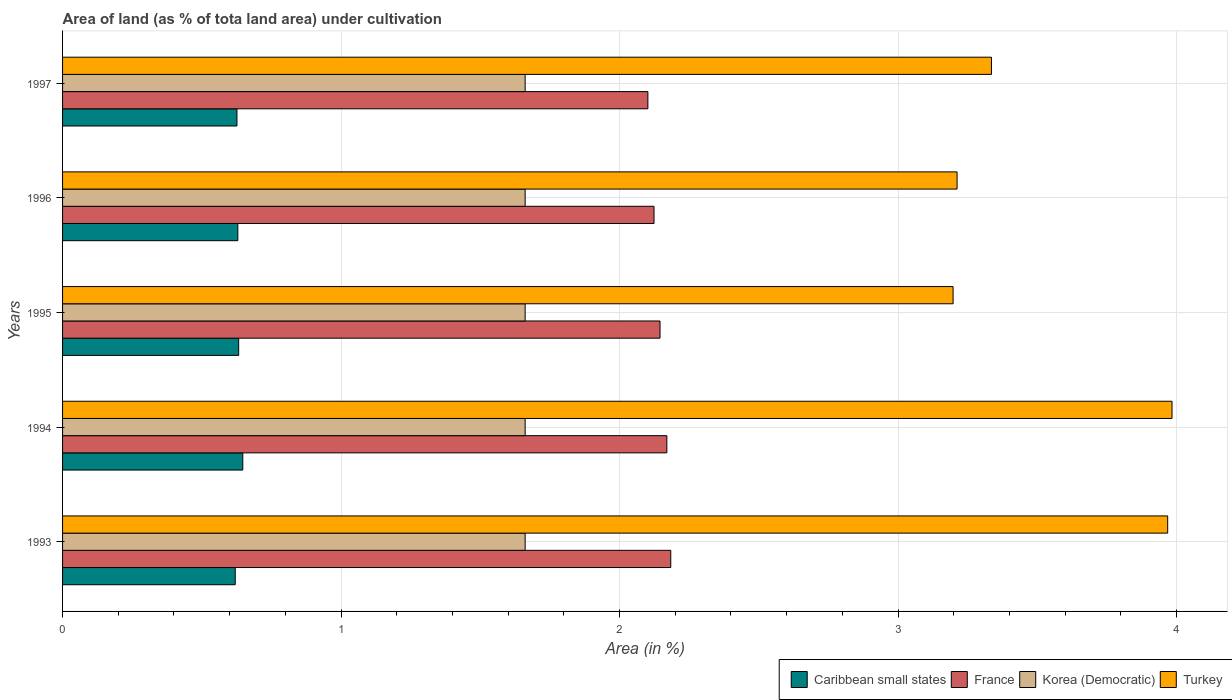How many groups of bars are there?
Make the answer very short. 5. How many bars are there on the 4th tick from the top?
Give a very brief answer. 4. How many bars are there on the 2nd tick from the bottom?
Offer a terse response. 4. What is the percentage of land under cultivation in France in 1997?
Offer a terse response. 2.1. Across all years, what is the maximum percentage of land under cultivation in Turkey?
Provide a short and direct response. 3.98. Across all years, what is the minimum percentage of land under cultivation in France?
Offer a very short reply. 2.1. In which year was the percentage of land under cultivation in Korea (Democratic) maximum?
Your response must be concise. 1993. What is the total percentage of land under cultivation in Caribbean small states in the graph?
Provide a short and direct response. 3.15. What is the difference between the percentage of land under cultivation in France in 1995 and that in 1997?
Offer a terse response. 0.04. What is the difference between the percentage of land under cultivation in Turkey in 1993 and the percentage of land under cultivation in Korea (Democratic) in 1994?
Offer a terse response. 2.31. What is the average percentage of land under cultivation in Turkey per year?
Your answer should be very brief. 3.54. In the year 1995, what is the difference between the percentage of land under cultivation in Turkey and percentage of land under cultivation in France?
Provide a succinct answer. 1.05. In how many years, is the percentage of land under cultivation in France greater than 3.6 %?
Your response must be concise. 0. What is the ratio of the percentage of land under cultivation in Korea (Democratic) in 1993 to that in 1996?
Offer a terse response. 1. Is the percentage of land under cultivation in France in 1996 less than that in 1997?
Ensure brevity in your answer.  No. What is the difference between the highest and the second highest percentage of land under cultivation in Turkey?
Give a very brief answer. 0.02. What is the difference between the highest and the lowest percentage of land under cultivation in Korea (Democratic)?
Your answer should be compact. 0. In how many years, is the percentage of land under cultivation in Turkey greater than the average percentage of land under cultivation in Turkey taken over all years?
Provide a succinct answer. 2. Is the sum of the percentage of land under cultivation in Caribbean small states in 1995 and 1996 greater than the maximum percentage of land under cultivation in France across all years?
Your answer should be compact. No. What does the 4th bar from the top in 1995 represents?
Make the answer very short. Caribbean small states. What does the 3rd bar from the bottom in 1994 represents?
Offer a very short reply. Korea (Democratic). Is it the case that in every year, the sum of the percentage of land under cultivation in France and percentage of land under cultivation in Korea (Democratic) is greater than the percentage of land under cultivation in Turkey?
Your response must be concise. No. How many bars are there?
Provide a succinct answer. 20. Are all the bars in the graph horizontal?
Keep it short and to the point. Yes. How many years are there in the graph?
Make the answer very short. 5. What is the difference between two consecutive major ticks on the X-axis?
Ensure brevity in your answer.  1. Are the values on the major ticks of X-axis written in scientific E-notation?
Your answer should be very brief. No. Does the graph contain any zero values?
Your answer should be very brief. No. Does the graph contain grids?
Offer a terse response. Yes. How are the legend labels stacked?
Give a very brief answer. Horizontal. What is the title of the graph?
Keep it short and to the point. Area of land (as % of tota land area) under cultivation. What is the label or title of the X-axis?
Your answer should be compact. Area (in %). What is the label or title of the Y-axis?
Your response must be concise. Years. What is the Area (in %) of Caribbean small states in 1993?
Give a very brief answer. 0.62. What is the Area (in %) in France in 1993?
Your response must be concise. 2.18. What is the Area (in %) in Korea (Democratic) in 1993?
Offer a terse response. 1.66. What is the Area (in %) of Turkey in 1993?
Provide a short and direct response. 3.97. What is the Area (in %) of Caribbean small states in 1994?
Give a very brief answer. 0.65. What is the Area (in %) in France in 1994?
Ensure brevity in your answer.  2.17. What is the Area (in %) in Korea (Democratic) in 1994?
Ensure brevity in your answer.  1.66. What is the Area (in %) of Turkey in 1994?
Keep it short and to the point. 3.98. What is the Area (in %) in Caribbean small states in 1995?
Your response must be concise. 0.63. What is the Area (in %) of France in 1995?
Keep it short and to the point. 2.15. What is the Area (in %) of Korea (Democratic) in 1995?
Your response must be concise. 1.66. What is the Area (in %) in Turkey in 1995?
Offer a very short reply. 3.2. What is the Area (in %) in Caribbean small states in 1996?
Ensure brevity in your answer.  0.63. What is the Area (in %) of France in 1996?
Give a very brief answer. 2.12. What is the Area (in %) of Korea (Democratic) in 1996?
Your answer should be compact. 1.66. What is the Area (in %) of Turkey in 1996?
Offer a very short reply. 3.21. What is the Area (in %) in Caribbean small states in 1997?
Give a very brief answer. 0.63. What is the Area (in %) in France in 1997?
Your response must be concise. 2.1. What is the Area (in %) of Korea (Democratic) in 1997?
Offer a very short reply. 1.66. What is the Area (in %) of Turkey in 1997?
Your answer should be compact. 3.34. Across all years, what is the maximum Area (in %) in Caribbean small states?
Ensure brevity in your answer.  0.65. Across all years, what is the maximum Area (in %) of France?
Your response must be concise. 2.18. Across all years, what is the maximum Area (in %) of Korea (Democratic)?
Give a very brief answer. 1.66. Across all years, what is the maximum Area (in %) of Turkey?
Provide a short and direct response. 3.98. Across all years, what is the minimum Area (in %) in Caribbean small states?
Your response must be concise. 0.62. Across all years, what is the minimum Area (in %) of France?
Provide a short and direct response. 2.1. Across all years, what is the minimum Area (in %) in Korea (Democratic)?
Provide a short and direct response. 1.66. Across all years, what is the minimum Area (in %) in Turkey?
Offer a terse response. 3.2. What is the total Area (in %) of Caribbean small states in the graph?
Keep it short and to the point. 3.15. What is the total Area (in %) of France in the graph?
Provide a short and direct response. 10.72. What is the total Area (in %) in Korea (Democratic) in the graph?
Provide a short and direct response. 8.3. What is the total Area (in %) of Turkey in the graph?
Make the answer very short. 17.7. What is the difference between the Area (in %) of Caribbean small states in 1993 and that in 1994?
Offer a very short reply. -0.03. What is the difference between the Area (in %) of France in 1993 and that in 1994?
Give a very brief answer. 0.01. What is the difference between the Area (in %) of Korea (Democratic) in 1993 and that in 1994?
Your answer should be very brief. 0. What is the difference between the Area (in %) of Turkey in 1993 and that in 1994?
Offer a very short reply. -0.02. What is the difference between the Area (in %) in Caribbean small states in 1993 and that in 1995?
Give a very brief answer. -0.01. What is the difference between the Area (in %) in France in 1993 and that in 1995?
Your answer should be very brief. 0.04. What is the difference between the Area (in %) of Turkey in 1993 and that in 1995?
Offer a very short reply. 0.77. What is the difference between the Area (in %) of Caribbean small states in 1993 and that in 1996?
Provide a short and direct response. -0.01. What is the difference between the Area (in %) of France in 1993 and that in 1996?
Your answer should be compact. 0.06. What is the difference between the Area (in %) of Turkey in 1993 and that in 1996?
Make the answer very short. 0.76. What is the difference between the Area (in %) of Caribbean small states in 1993 and that in 1997?
Offer a terse response. -0.01. What is the difference between the Area (in %) in France in 1993 and that in 1997?
Make the answer very short. 0.08. What is the difference between the Area (in %) in Turkey in 1993 and that in 1997?
Provide a succinct answer. 0.63. What is the difference between the Area (in %) of Caribbean small states in 1994 and that in 1995?
Your response must be concise. 0.01. What is the difference between the Area (in %) in France in 1994 and that in 1995?
Offer a terse response. 0.02. What is the difference between the Area (in %) in Turkey in 1994 and that in 1995?
Make the answer very short. 0.79. What is the difference between the Area (in %) in Caribbean small states in 1994 and that in 1996?
Keep it short and to the point. 0.02. What is the difference between the Area (in %) in France in 1994 and that in 1996?
Keep it short and to the point. 0.05. What is the difference between the Area (in %) in Turkey in 1994 and that in 1996?
Offer a very short reply. 0.77. What is the difference between the Area (in %) of Caribbean small states in 1994 and that in 1997?
Make the answer very short. 0.02. What is the difference between the Area (in %) in France in 1994 and that in 1997?
Make the answer very short. 0.07. What is the difference between the Area (in %) in Turkey in 1994 and that in 1997?
Make the answer very short. 0.65. What is the difference between the Area (in %) of Caribbean small states in 1995 and that in 1996?
Give a very brief answer. 0. What is the difference between the Area (in %) in France in 1995 and that in 1996?
Ensure brevity in your answer.  0.02. What is the difference between the Area (in %) of Korea (Democratic) in 1995 and that in 1996?
Provide a short and direct response. 0. What is the difference between the Area (in %) in Turkey in 1995 and that in 1996?
Provide a succinct answer. -0.01. What is the difference between the Area (in %) in Caribbean small states in 1995 and that in 1997?
Provide a short and direct response. 0.01. What is the difference between the Area (in %) in France in 1995 and that in 1997?
Give a very brief answer. 0.04. What is the difference between the Area (in %) of Korea (Democratic) in 1995 and that in 1997?
Your response must be concise. 0. What is the difference between the Area (in %) in Turkey in 1995 and that in 1997?
Offer a terse response. -0.14. What is the difference between the Area (in %) of Caribbean small states in 1996 and that in 1997?
Provide a short and direct response. 0. What is the difference between the Area (in %) in France in 1996 and that in 1997?
Keep it short and to the point. 0.02. What is the difference between the Area (in %) in Korea (Democratic) in 1996 and that in 1997?
Keep it short and to the point. 0. What is the difference between the Area (in %) of Turkey in 1996 and that in 1997?
Provide a short and direct response. -0.12. What is the difference between the Area (in %) in Caribbean small states in 1993 and the Area (in %) in France in 1994?
Make the answer very short. -1.55. What is the difference between the Area (in %) of Caribbean small states in 1993 and the Area (in %) of Korea (Democratic) in 1994?
Give a very brief answer. -1.04. What is the difference between the Area (in %) of Caribbean small states in 1993 and the Area (in %) of Turkey in 1994?
Provide a succinct answer. -3.36. What is the difference between the Area (in %) in France in 1993 and the Area (in %) in Korea (Democratic) in 1994?
Your answer should be compact. 0.52. What is the difference between the Area (in %) of France in 1993 and the Area (in %) of Turkey in 1994?
Offer a very short reply. -1.8. What is the difference between the Area (in %) in Korea (Democratic) in 1993 and the Area (in %) in Turkey in 1994?
Provide a short and direct response. -2.32. What is the difference between the Area (in %) of Caribbean small states in 1993 and the Area (in %) of France in 1995?
Provide a succinct answer. -1.53. What is the difference between the Area (in %) in Caribbean small states in 1993 and the Area (in %) in Korea (Democratic) in 1995?
Offer a very short reply. -1.04. What is the difference between the Area (in %) in Caribbean small states in 1993 and the Area (in %) in Turkey in 1995?
Provide a succinct answer. -2.58. What is the difference between the Area (in %) of France in 1993 and the Area (in %) of Korea (Democratic) in 1995?
Provide a short and direct response. 0.52. What is the difference between the Area (in %) of France in 1993 and the Area (in %) of Turkey in 1995?
Provide a short and direct response. -1.01. What is the difference between the Area (in %) in Korea (Democratic) in 1993 and the Area (in %) in Turkey in 1995?
Your response must be concise. -1.54. What is the difference between the Area (in %) of Caribbean small states in 1993 and the Area (in %) of France in 1996?
Keep it short and to the point. -1.5. What is the difference between the Area (in %) in Caribbean small states in 1993 and the Area (in %) in Korea (Democratic) in 1996?
Give a very brief answer. -1.04. What is the difference between the Area (in %) of Caribbean small states in 1993 and the Area (in %) of Turkey in 1996?
Provide a succinct answer. -2.59. What is the difference between the Area (in %) in France in 1993 and the Area (in %) in Korea (Democratic) in 1996?
Make the answer very short. 0.52. What is the difference between the Area (in %) of France in 1993 and the Area (in %) of Turkey in 1996?
Your answer should be very brief. -1.03. What is the difference between the Area (in %) in Korea (Democratic) in 1993 and the Area (in %) in Turkey in 1996?
Offer a terse response. -1.55. What is the difference between the Area (in %) in Caribbean small states in 1993 and the Area (in %) in France in 1997?
Give a very brief answer. -1.48. What is the difference between the Area (in %) in Caribbean small states in 1993 and the Area (in %) in Korea (Democratic) in 1997?
Your answer should be compact. -1.04. What is the difference between the Area (in %) in Caribbean small states in 1993 and the Area (in %) in Turkey in 1997?
Offer a terse response. -2.72. What is the difference between the Area (in %) in France in 1993 and the Area (in %) in Korea (Democratic) in 1997?
Provide a succinct answer. 0.52. What is the difference between the Area (in %) of France in 1993 and the Area (in %) of Turkey in 1997?
Your answer should be compact. -1.15. What is the difference between the Area (in %) of Korea (Democratic) in 1993 and the Area (in %) of Turkey in 1997?
Offer a very short reply. -1.67. What is the difference between the Area (in %) in Caribbean small states in 1994 and the Area (in %) in France in 1995?
Offer a terse response. -1.5. What is the difference between the Area (in %) in Caribbean small states in 1994 and the Area (in %) in Korea (Democratic) in 1995?
Your answer should be very brief. -1.01. What is the difference between the Area (in %) of Caribbean small states in 1994 and the Area (in %) of Turkey in 1995?
Keep it short and to the point. -2.55. What is the difference between the Area (in %) in France in 1994 and the Area (in %) in Korea (Democratic) in 1995?
Make the answer very short. 0.51. What is the difference between the Area (in %) in France in 1994 and the Area (in %) in Turkey in 1995?
Keep it short and to the point. -1.03. What is the difference between the Area (in %) in Korea (Democratic) in 1994 and the Area (in %) in Turkey in 1995?
Give a very brief answer. -1.54. What is the difference between the Area (in %) in Caribbean small states in 1994 and the Area (in %) in France in 1996?
Offer a terse response. -1.48. What is the difference between the Area (in %) in Caribbean small states in 1994 and the Area (in %) in Korea (Democratic) in 1996?
Keep it short and to the point. -1.01. What is the difference between the Area (in %) in Caribbean small states in 1994 and the Area (in %) in Turkey in 1996?
Make the answer very short. -2.56. What is the difference between the Area (in %) of France in 1994 and the Area (in %) of Korea (Democratic) in 1996?
Make the answer very short. 0.51. What is the difference between the Area (in %) in France in 1994 and the Area (in %) in Turkey in 1996?
Offer a very short reply. -1.04. What is the difference between the Area (in %) of Korea (Democratic) in 1994 and the Area (in %) of Turkey in 1996?
Make the answer very short. -1.55. What is the difference between the Area (in %) in Caribbean small states in 1994 and the Area (in %) in France in 1997?
Your answer should be very brief. -1.45. What is the difference between the Area (in %) in Caribbean small states in 1994 and the Area (in %) in Korea (Democratic) in 1997?
Your answer should be compact. -1.01. What is the difference between the Area (in %) of Caribbean small states in 1994 and the Area (in %) of Turkey in 1997?
Your answer should be compact. -2.69. What is the difference between the Area (in %) in France in 1994 and the Area (in %) in Korea (Democratic) in 1997?
Keep it short and to the point. 0.51. What is the difference between the Area (in %) of France in 1994 and the Area (in %) of Turkey in 1997?
Provide a succinct answer. -1.17. What is the difference between the Area (in %) in Korea (Democratic) in 1994 and the Area (in %) in Turkey in 1997?
Offer a terse response. -1.67. What is the difference between the Area (in %) in Caribbean small states in 1995 and the Area (in %) in France in 1996?
Your answer should be very brief. -1.49. What is the difference between the Area (in %) in Caribbean small states in 1995 and the Area (in %) in Korea (Democratic) in 1996?
Provide a short and direct response. -1.03. What is the difference between the Area (in %) in Caribbean small states in 1995 and the Area (in %) in Turkey in 1996?
Your answer should be compact. -2.58. What is the difference between the Area (in %) of France in 1995 and the Area (in %) of Korea (Democratic) in 1996?
Give a very brief answer. 0.48. What is the difference between the Area (in %) of France in 1995 and the Area (in %) of Turkey in 1996?
Make the answer very short. -1.07. What is the difference between the Area (in %) of Korea (Democratic) in 1995 and the Area (in %) of Turkey in 1996?
Your answer should be very brief. -1.55. What is the difference between the Area (in %) in Caribbean small states in 1995 and the Area (in %) in France in 1997?
Your answer should be compact. -1.47. What is the difference between the Area (in %) in Caribbean small states in 1995 and the Area (in %) in Korea (Democratic) in 1997?
Offer a very short reply. -1.03. What is the difference between the Area (in %) in Caribbean small states in 1995 and the Area (in %) in Turkey in 1997?
Your answer should be very brief. -2.7. What is the difference between the Area (in %) of France in 1995 and the Area (in %) of Korea (Democratic) in 1997?
Keep it short and to the point. 0.48. What is the difference between the Area (in %) in France in 1995 and the Area (in %) in Turkey in 1997?
Provide a short and direct response. -1.19. What is the difference between the Area (in %) in Korea (Democratic) in 1995 and the Area (in %) in Turkey in 1997?
Your response must be concise. -1.67. What is the difference between the Area (in %) of Caribbean small states in 1996 and the Area (in %) of France in 1997?
Your answer should be very brief. -1.47. What is the difference between the Area (in %) of Caribbean small states in 1996 and the Area (in %) of Korea (Democratic) in 1997?
Give a very brief answer. -1.03. What is the difference between the Area (in %) of Caribbean small states in 1996 and the Area (in %) of Turkey in 1997?
Provide a succinct answer. -2.71. What is the difference between the Area (in %) of France in 1996 and the Area (in %) of Korea (Democratic) in 1997?
Ensure brevity in your answer.  0.46. What is the difference between the Area (in %) of France in 1996 and the Area (in %) of Turkey in 1997?
Offer a very short reply. -1.21. What is the difference between the Area (in %) in Korea (Democratic) in 1996 and the Area (in %) in Turkey in 1997?
Offer a very short reply. -1.67. What is the average Area (in %) of Caribbean small states per year?
Give a very brief answer. 0.63. What is the average Area (in %) of France per year?
Ensure brevity in your answer.  2.14. What is the average Area (in %) of Korea (Democratic) per year?
Your answer should be compact. 1.66. What is the average Area (in %) of Turkey per year?
Make the answer very short. 3.54. In the year 1993, what is the difference between the Area (in %) in Caribbean small states and Area (in %) in France?
Provide a succinct answer. -1.56. In the year 1993, what is the difference between the Area (in %) in Caribbean small states and Area (in %) in Korea (Democratic)?
Give a very brief answer. -1.04. In the year 1993, what is the difference between the Area (in %) in Caribbean small states and Area (in %) in Turkey?
Keep it short and to the point. -3.35. In the year 1993, what is the difference between the Area (in %) in France and Area (in %) in Korea (Democratic)?
Your response must be concise. 0.52. In the year 1993, what is the difference between the Area (in %) in France and Area (in %) in Turkey?
Make the answer very short. -1.78. In the year 1993, what is the difference between the Area (in %) of Korea (Democratic) and Area (in %) of Turkey?
Make the answer very short. -2.31. In the year 1994, what is the difference between the Area (in %) of Caribbean small states and Area (in %) of France?
Make the answer very short. -1.52. In the year 1994, what is the difference between the Area (in %) of Caribbean small states and Area (in %) of Korea (Democratic)?
Keep it short and to the point. -1.01. In the year 1994, what is the difference between the Area (in %) in Caribbean small states and Area (in %) in Turkey?
Provide a succinct answer. -3.34. In the year 1994, what is the difference between the Area (in %) of France and Area (in %) of Korea (Democratic)?
Give a very brief answer. 0.51. In the year 1994, what is the difference between the Area (in %) in France and Area (in %) in Turkey?
Offer a terse response. -1.81. In the year 1994, what is the difference between the Area (in %) of Korea (Democratic) and Area (in %) of Turkey?
Your answer should be compact. -2.32. In the year 1995, what is the difference between the Area (in %) in Caribbean small states and Area (in %) in France?
Offer a terse response. -1.51. In the year 1995, what is the difference between the Area (in %) of Caribbean small states and Area (in %) of Korea (Democratic)?
Provide a short and direct response. -1.03. In the year 1995, what is the difference between the Area (in %) of Caribbean small states and Area (in %) of Turkey?
Your answer should be very brief. -2.57. In the year 1995, what is the difference between the Area (in %) of France and Area (in %) of Korea (Democratic)?
Provide a succinct answer. 0.48. In the year 1995, what is the difference between the Area (in %) of France and Area (in %) of Turkey?
Offer a very short reply. -1.05. In the year 1995, what is the difference between the Area (in %) in Korea (Democratic) and Area (in %) in Turkey?
Your answer should be very brief. -1.54. In the year 1996, what is the difference between the Area (in %) of Caribbean small states and Area (in %) of France?
Provide a succinct answer. -1.49. In the year 1996, what is the difference between the Area (in %) in Caribbean small states and Area (in %) in Korea (Democratic)?
Ensure brevity in your answer.  -1.03. In the year 1996, what is the difference between the Area (in %) in Caribbean small states and Area (in %) in Turkey?
Your response must be concise. -2.58. In the year 1996, what is the difference between the Area (in %) in France and Area (in %) in Korea (Democratic)?
Keep it short and to the point. 0.46. In the year 1996, what is the difference between the Area (in %) in France and Area (in %) in Turkey?
Your answer should be very brief. -1.09. In the year 1996, what is the difference between the Area (in %) in Korea (Democratic) and Area (in %) in Turkey?
Keep it short and to the point. -1.55. In the year 1997, what is the difference between the Area (in %) in Caribbean small states and Area (in %) in France?
Make the answer very short. -1.48. In the year 1997, what is the difference between the Area (in %) of Caribbean small states and Area (in %) of Korea (Democratic)?
Provide a short and direct response. -1.03. In the year 1997, what is the difference between the Area (in %) in Caribbean small states and Area (in %) in Turkey?
Make the answer very short. -2.71. In the year 1997, what is the difference between the Area (in %) of France and Area (in %) of Korea (Democratic)?
Provide a succinct answer. 0.44. In the year 1997, what is the difference between the Area (in %) in France and Area (in %) in Turkey?
Provide a short and direct response. -1.23. In the year 1997, what is the difference between the Area (in %) in Korea (Democratic) and Area (in %) in Turkey?
Offer a very short reply. -1.67. What is the ratio of the Area (in %) of Caribbean small states in 1993 to that in 1994?
Offer a very short reply. 0.96. What is the ratio of the Area (in %) of France in 1993 to that in 1994?
Make the answer very short. 1.01. What is the ratio of the Area (in %) of Korea (Democratic) in 1993 to that in 1994?
Your response must be concise. 1. What is the ratio of the Area (in %) in Caribbean small states in 1993 to that in 1995?
Offer a very short reply. 0.98. What is the ratio of the Area (in %) of France in 1993 to that in 1995?
Your answer should be very brief. 1.02. What is the ratio of the Area (in %) of Turkey in 1993 to that in 1995?
Ensure brevity in your answer.  1.24. What is the ratio of the Area (in %) in Caribbean small states in 1993 to that in 1996?
Ensure brevity in your answer.  0.99. What is the ratio of the Area (in %) of France in 1993 to that in 1996?
Offer a very short reply. 1.03. What is the ratio of the Area (in %) of Korea (Democratic) in 1993 to that in 1996?
Your response must be concise. 1. What is the ratio of the Area (in %) in Turkey in 1993 to that in 1996?
Keep it short and to the point. 1.24. What is the ratio of the Area (in %) of France in 1993 to that in 1997?
Provide a succinct answer. 1.04. What is the ratio of the Area (in %) of Korea (Democratic) in 1993 to that in 1997?
Make the answer very short. 1. What is the ratio of the Area (in %) in Turkey in 1993 to that in 1997?
Ensure brevity in your answer.  1.19. What is the ratio of the Area (in %) in Caribbean small states in 1994 to that in 1995?
Your response must be concise. 1.02. What is the ratio of the Area (in %) of France in 1994 to that in 1995?
Make the answer very short. 1.01. What is the ratio of the Area (in %) of Korea (Democratic) in 1994 to that in 1995?
Your response must be concise. 1. What is the ratio of the Area (in %) in Turkey in 1994 to that in 1995?
Offer a very short reply. 1.25. What is the ratio of the Area (in %) of Caribbean small states in 1994 to that in 1996?
Ensure brevity in your answer.  1.03. What is the ratio of the Area (in %) of France in 1994 to that in 1996?
Your answer should be very brief. 1.02. What is the ratio of the Area (in %) in Turkey in 1994 to that in 1996?
Keep it short and to the point. 1.24. What is the ratio of the Area (in %) of Caribbean small states in 1994 to that in 1997?
Ensure brevity in your answer.  1.03. What is the ratio of the Area (in %) of France in 1994 to that in 1997?
Offer a very short reply. 1.03. What is the ratio of the Area (in %) in Turkey in 1994 to that in 1997?
Keep it short and to the point. 1.19. What is the ratio of the Area (in %) of Caribbean small states in 1995 to that in 1996?
Provide a short and direct response. 1. What is the ratio of the Area (in %) in Korea (Democratic) in 1995 to that in 1996?
Your response must be concise. 1. What is the ratio of the Area (in %) in Turkey in 1995 to that in 1996?
Offer a terse response. 1. What is the ratio of the Area (in %) in Caribbean small states in 1995 to that in 1997?
Your answer should be very brief. 1.01. What is the ratio of the Area (in %) in France in 1995 to that in 1997?
Your answer should be compact. 1.02. What is the ratio of the Area (in %) of Korea (Democratic) in 1995 to that in 1997?
Give a very brief answer. 1. What is the ratio of the Area (in %) of Turkey in 1995 to that in 1997?
Make the answer very short. 0.96. What is the ratio of the Area (in %) of France in 1996 to that in 1997?
Your response must be concise. 1.01. What is the difference between the highest and the second highest Area (in %) in Caribbean small states?
Offer a terse response. 0.01. What is the difference between the highest and the second highest Area (in %) of France?
Offer a very short reply. 0.01. What is the difference between the highest and the second highest Area (in %) in Turkey?
Offer a terse response. 0.02. What is the difference between the highest and the lowest Area (in %) of Caribbean small states?
Ensure brevity in your answer.  0.03. What is the difference between the highest and the lowest Area (in %) of France?
Your answer should be very brief. 0.08. What is the difference between the highest and the lowest Area (in %) in Turkey?
Make the answer very short. 0.79. 